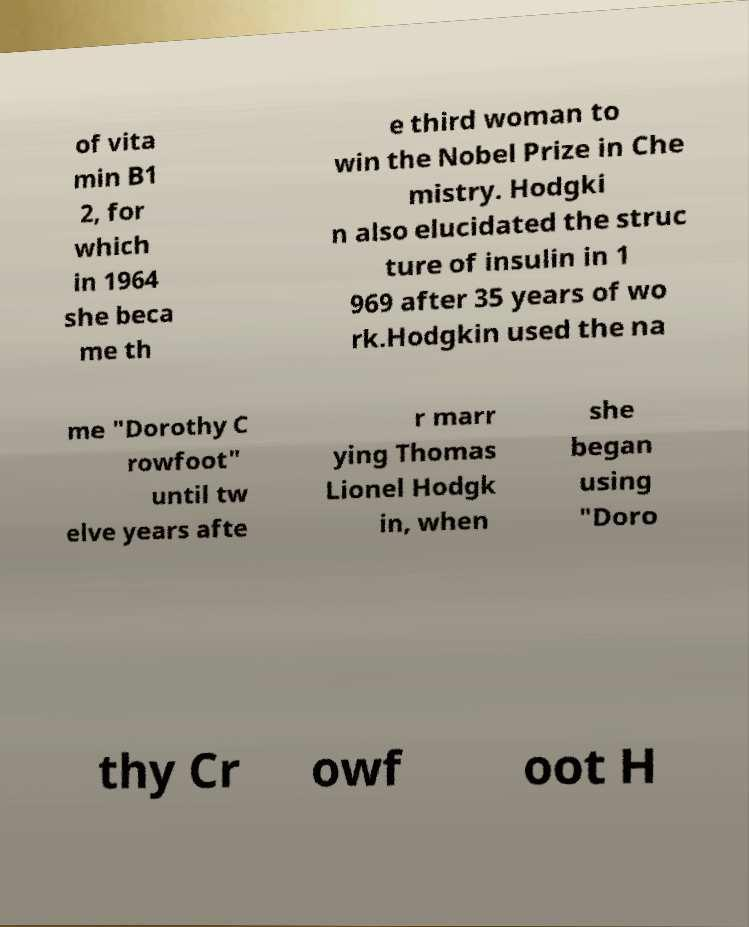Please identify and transcribe the text found in this image. of vita min B1 2, for which in 1964 she beca me th e third woman to win the Nobel Prize in Che mistry. Hodgki n also elucidated the struc ture of insulin in 1 969 after 35 years of wo rk.Hodgkin used the na me "Dorothy C rowfoot" until tw elve years afte r marr ying Thomas Lionel Hodgk in, when she began using "Doro thy Cr owf oot H 